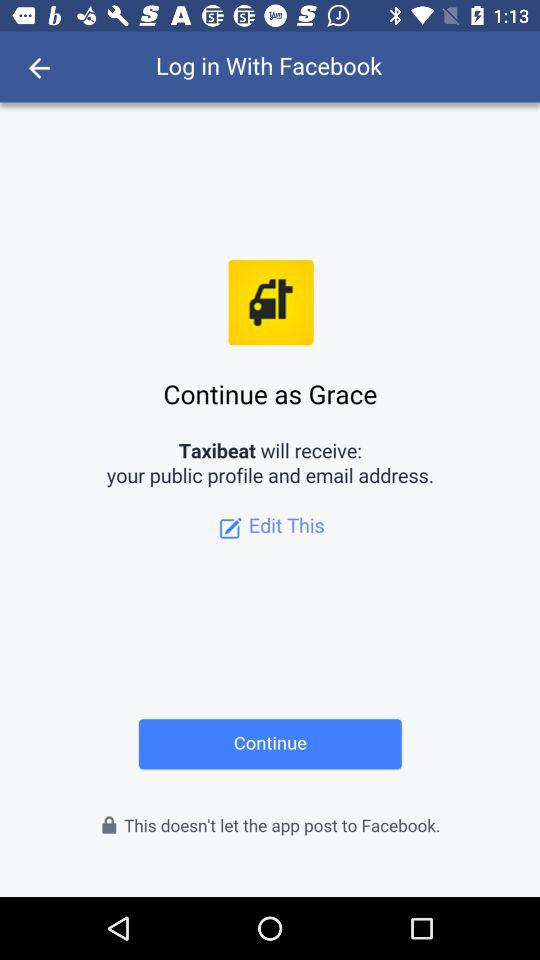What is the login name? The login name is Grace. 